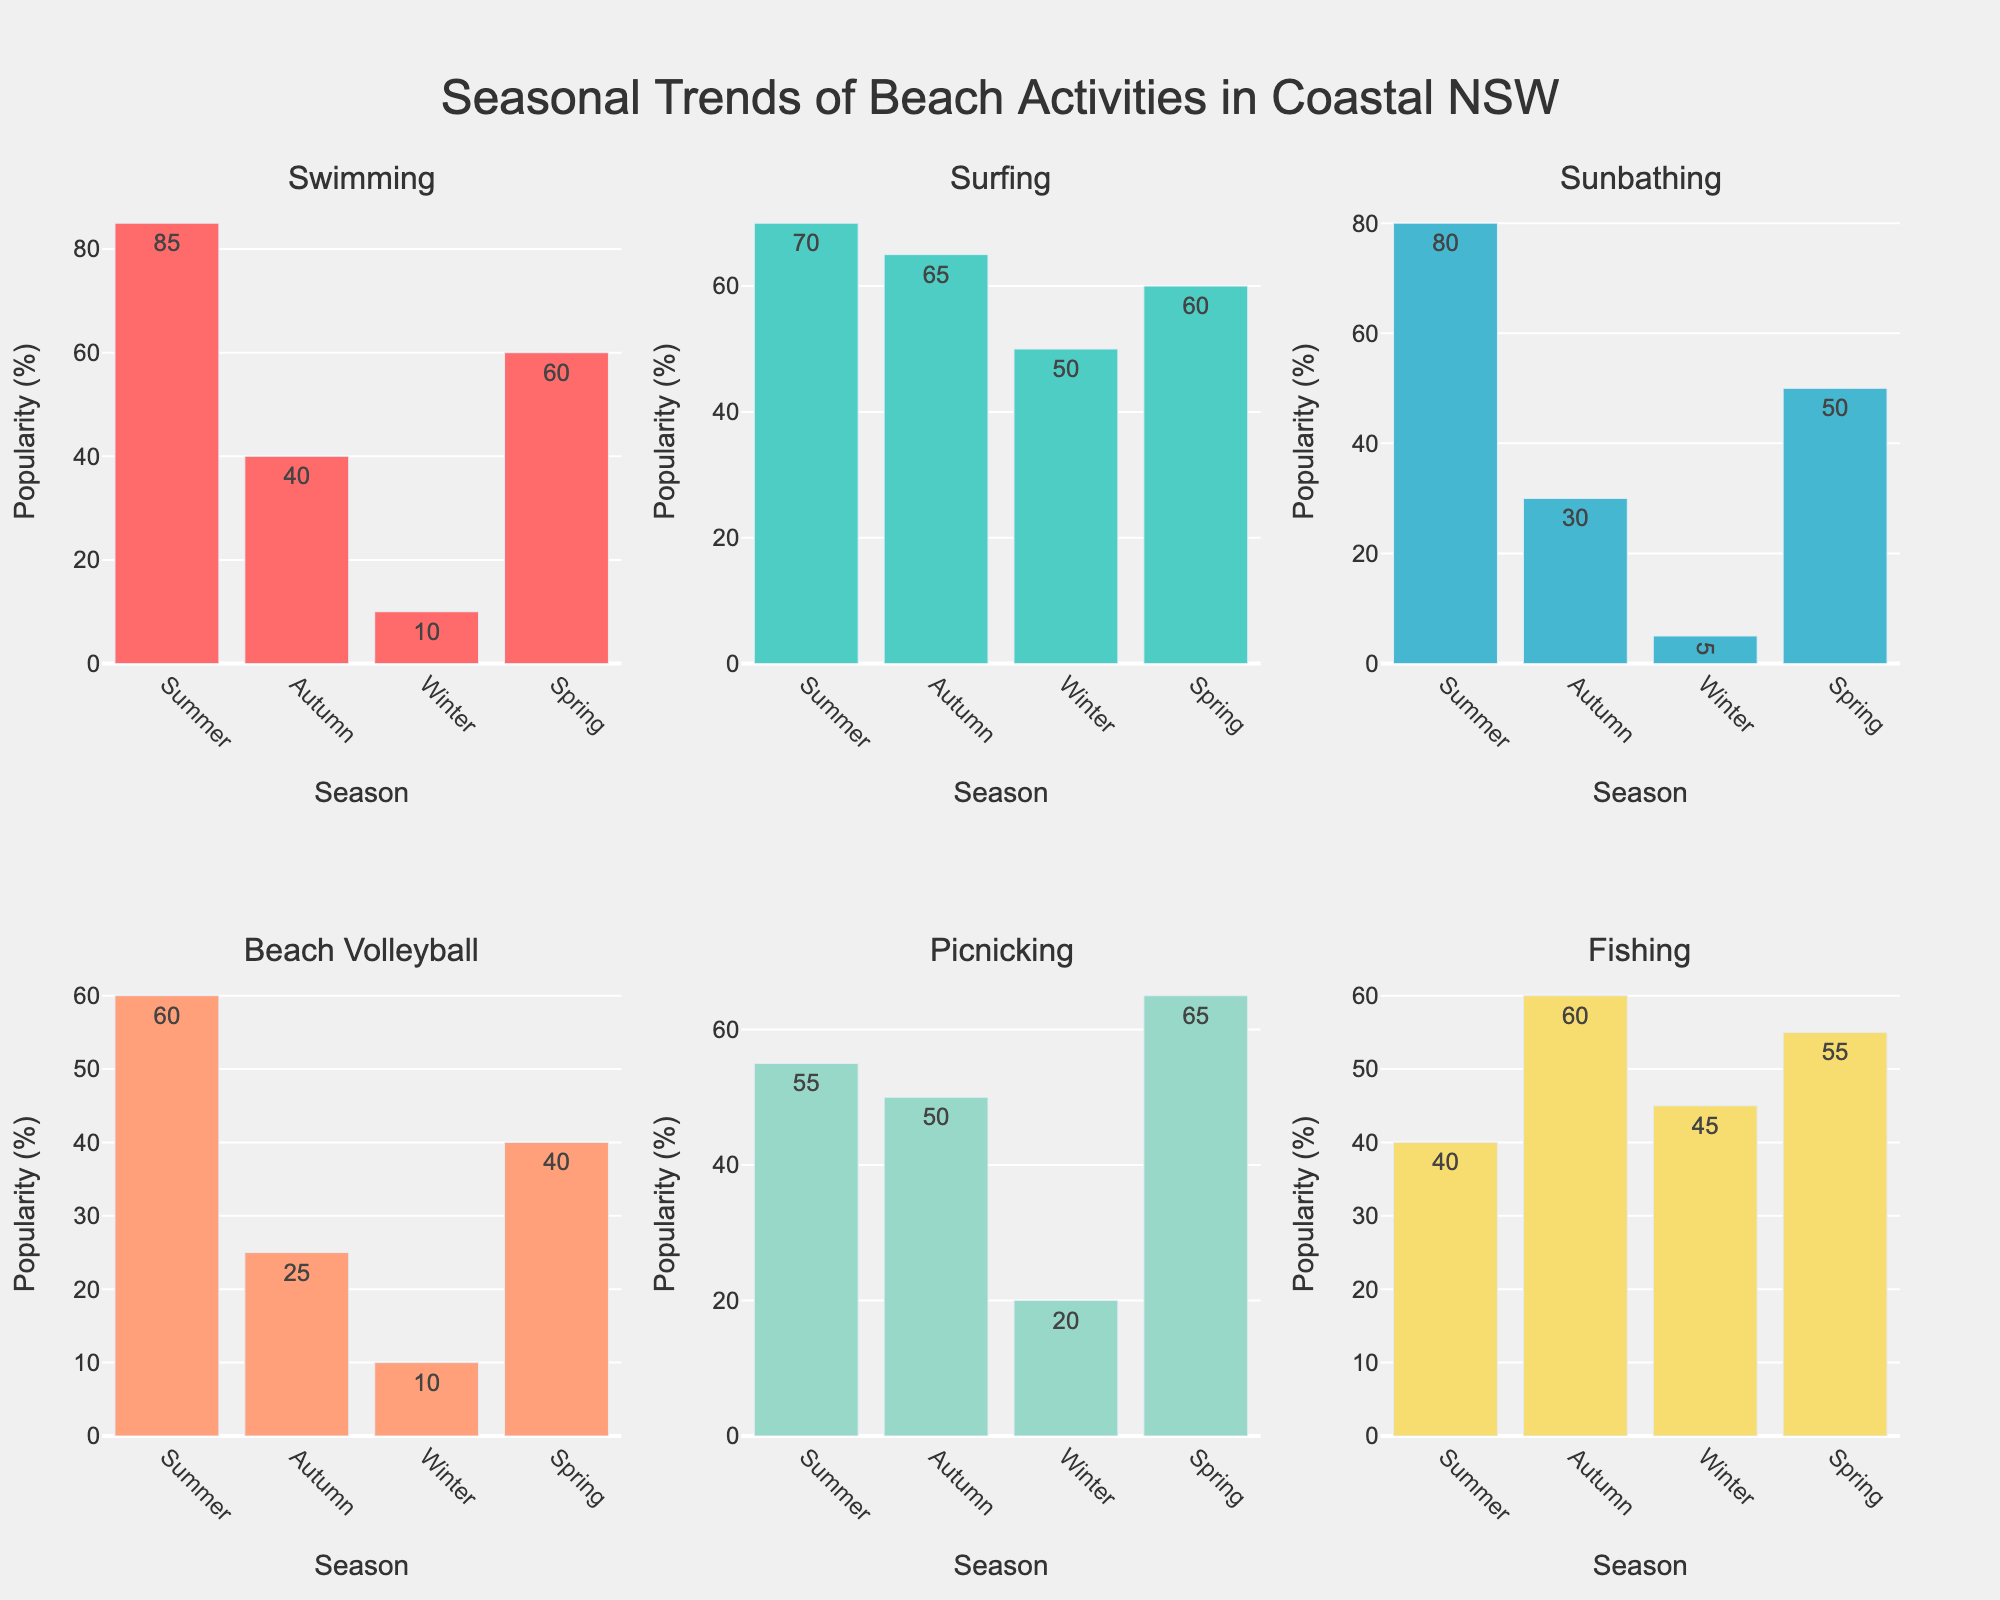What is the title of the figure? The title of a figure is typically displayed prominently at the top of the chart. In this case, it reads "Seasonal Trends of Beach Activities in Coastal NSW".
Answer: Seasonal Trends of Beach Activities in Coastal NSW How many seasons are displayed on each subplot? Each subplot presents data for all four seasons. We can confirm this by looking at the x-axis labels, which include Summer, Autumn, Winter, and Spring.
Answer: 4 Which activity is the least popular in Winter? By examining the Winter bars across all subplots, the shortest bar corresponds to Sunbathing, indicating it's the least popular activity during Winter.
Answer: Sunbathing Which season has the highest popularity for Swimming? In the Swimming subplot, the tallest bar represents the highest popularity. By observing the seasons on the x-axis, it is evident that Summer has the tallest bar.
Answer: Summer Compare the popularity of Fishing in Autumn and Summer. Which season is more popular and by how much? We observe the Fishing bars in both Autumn and Summer. Autumn has a popularity of 60, while Summer has 40. The difference is 60 - 40 = 20. Autumn is more popular by 20.
Answer: Autumn, 20 What is the average popularity of Beach Volleyball across all seasons? To calculate the average, add the popularity values across all seasons and divide by the number of seasons: (60 + 25 + 10 + 40) / 4 = 135 / 4 = 33.75.
Answer: 33.75 In which subplot is picnicking most popular, and during which season? By looking at the subplot for Picnicking, the tallest bar indicates the season of highest popularity. This occurs in Spring.
Answer: Spring Is Surfing more popular in Summer or Winter, and by what margin? Observing the bars for Surfing in Summer and Winter, Summer's popularity is 70, and Winter's is 50. The margin is 70 - 50 = 20.
Answer: Summer, 20 Calculate the total popularity across all activities for Summer. We sum the popularity values for Summer in all subplots: 85 + 70 + 80 + 60 + 55 + 40 = 390.
Answer: 390 